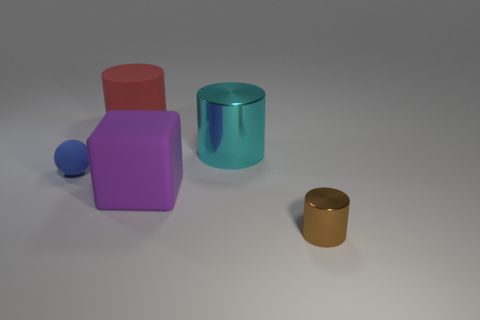Can you describe the objects in the image in terms of their shapes? Certainly! We have a collection of geometric shapes: there's a red cube, a purple cuboid, a smaller blue sphere, a teal cylinder, and a smaller gold cylinder. Which object appears to be the tallest and which is the smallest? The teal cylinder seems to be the tallest object in the image, while the blue sphere appears to be the smallest. 